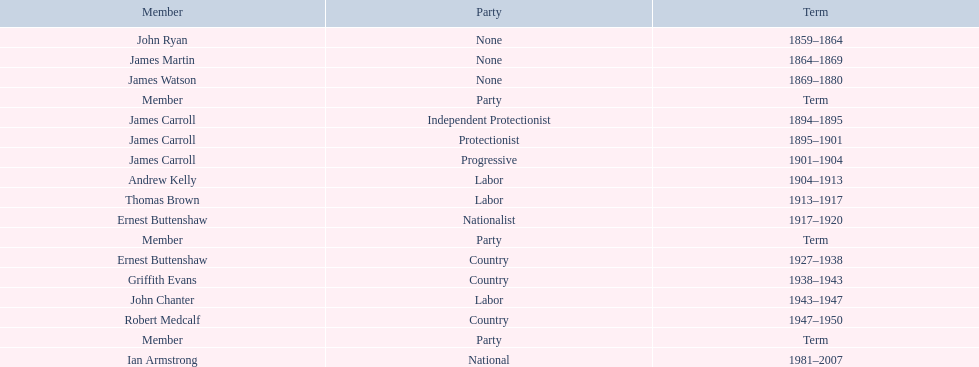Of the members of the third incarnation of the lachlan, who served the longest? Ernest Buttenshaw. 